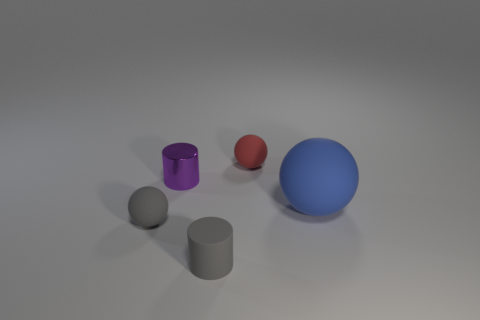Add 3 cylinders. How many objects exist? 8 Subtract all balls. How many objects are left? 2 Add 1 green metal blocks. How many green metal blocks exist? 1 Subtract 0 green blocks. How many objects are left? 5 Subtract all tiny red objects. Subtract all tiny balls. How many objects are left? 2 Add 4 tiny balls. How many tiny balls are left? 6 